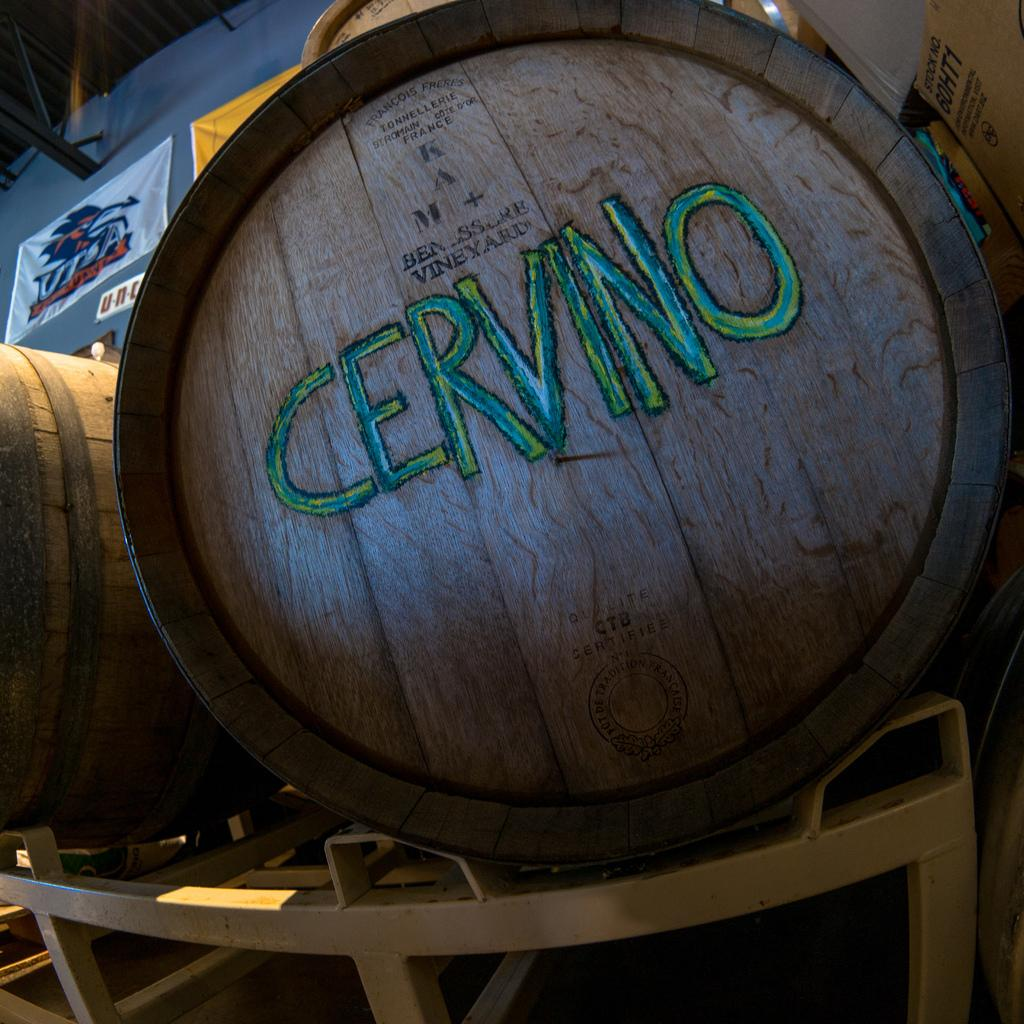What objects are present in the image that resemble large cylindrical containers? There are barrels in the image. How are the barrels positioned in the image? The barrels are on a metal stand. What can be seen on the surface of the barrels? There is text on the barrels. What type of decorative item is present in the image? There is a cloth with a picture in the image. Where is the cloth with a picture located? The cloth with a picture is on a wall. What key is used to unlock the top of the barrels in the image? There is no key or lock present on the barrels in the image. What sense is activated by the picture on the cloth in the image? The image does not depict any sensory stimuli, so it cannot activate a sense. 